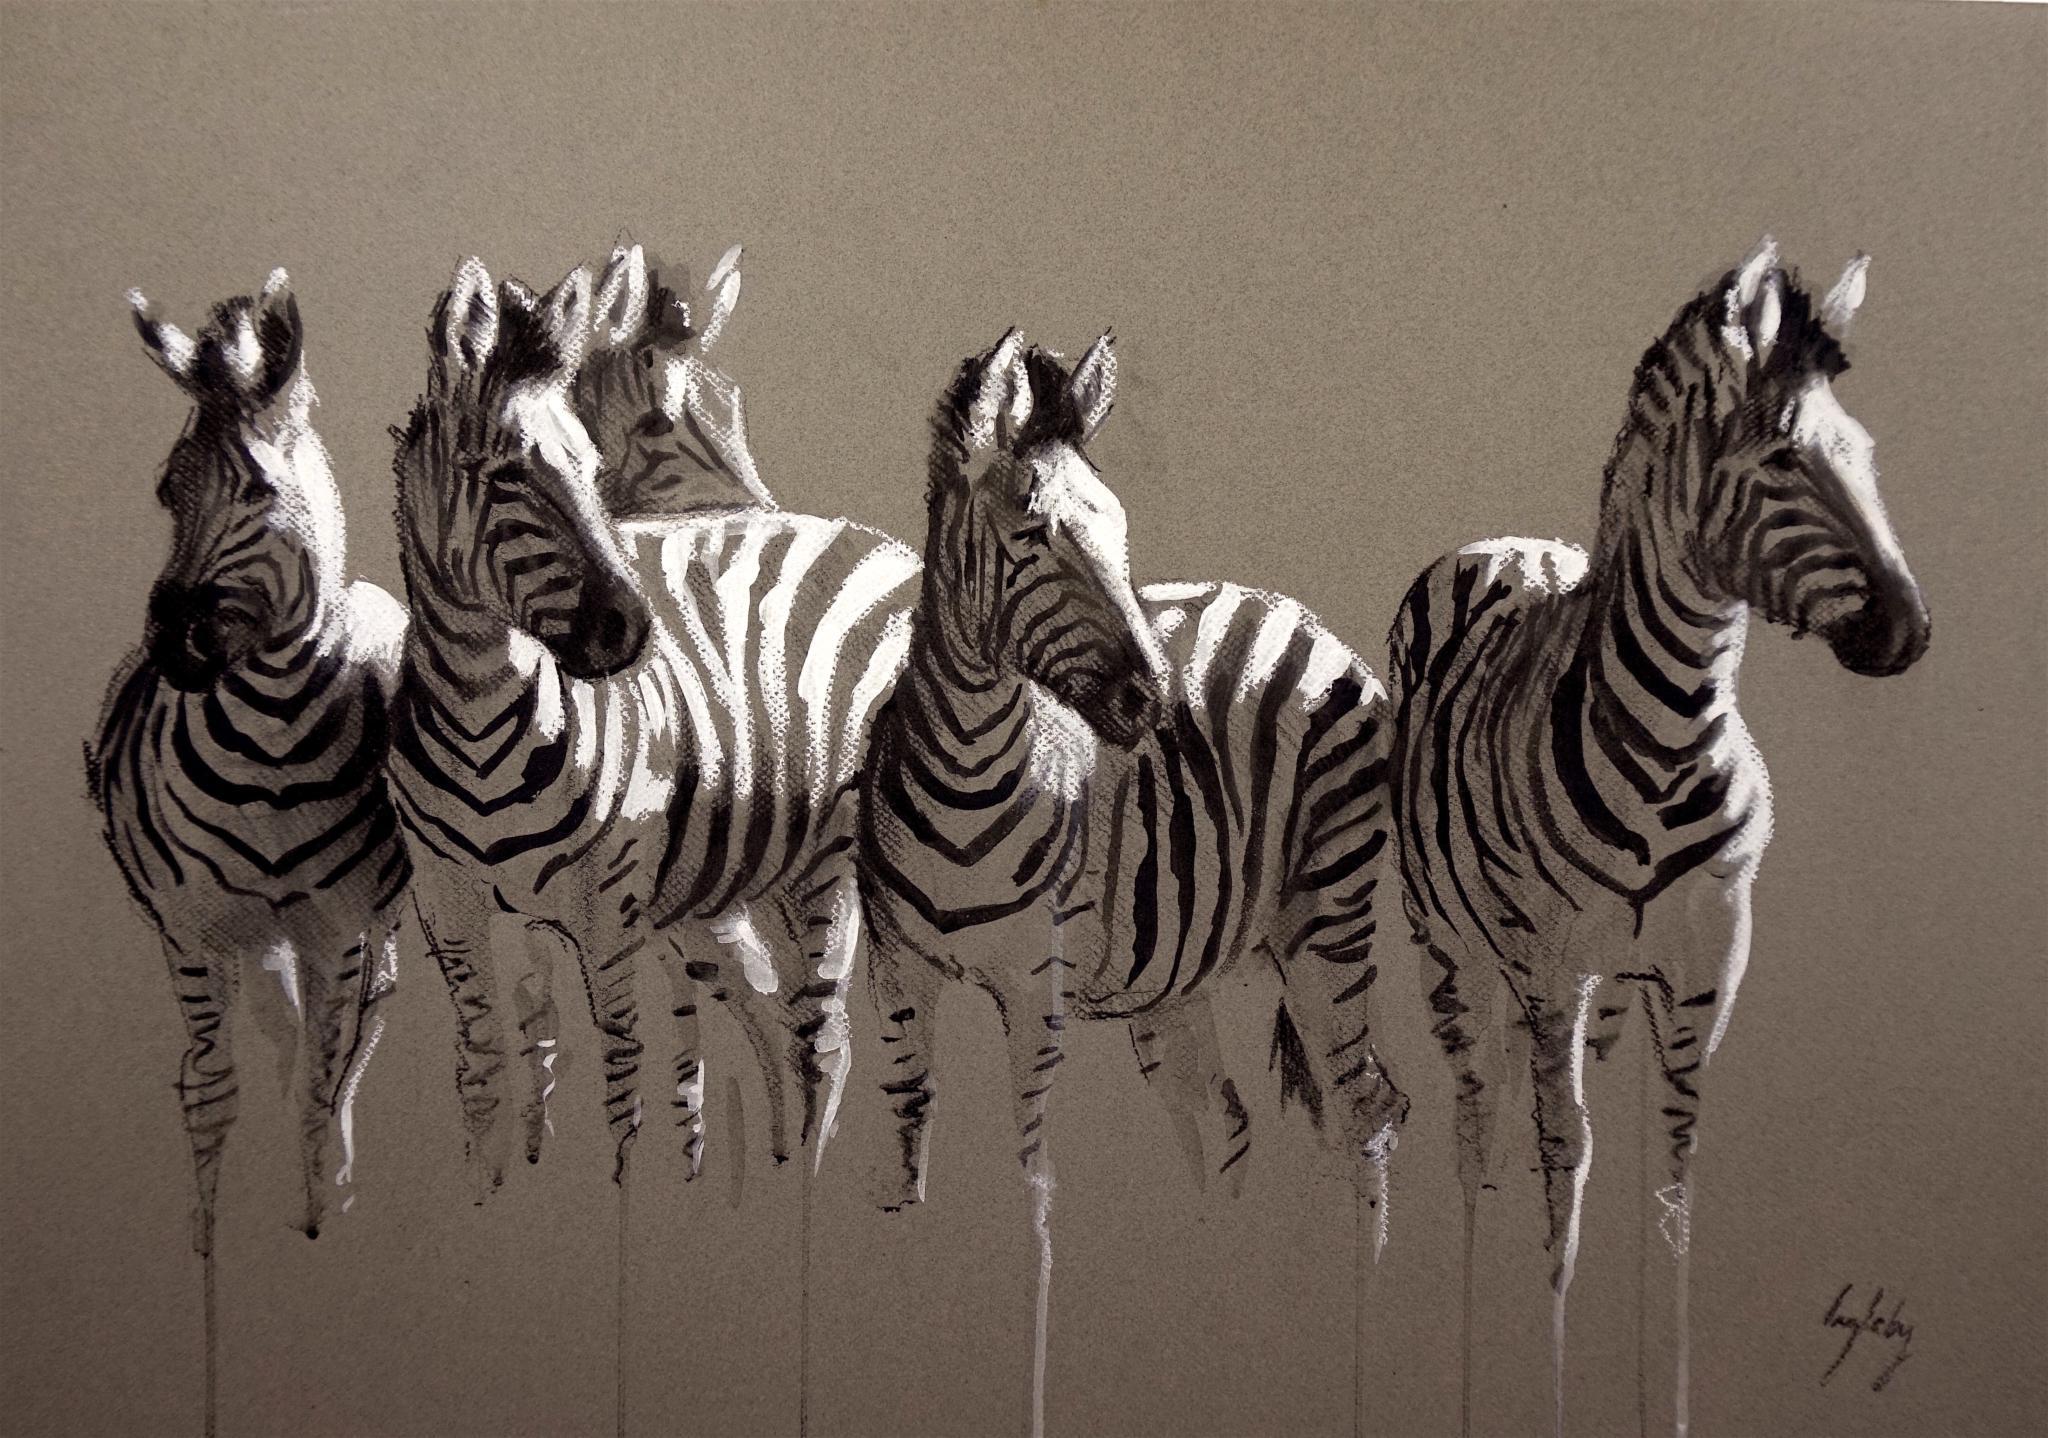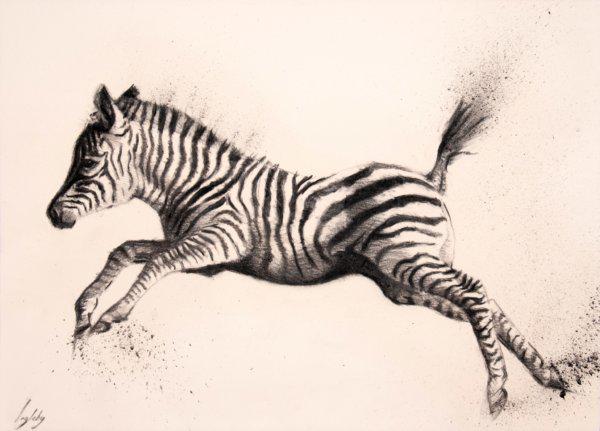The first image is the image on the left, the second image is the image on the right. Analyze the images presented: Is the assertion "There is only one zebra in the right image." valid? Answer yes or no. Yes. 